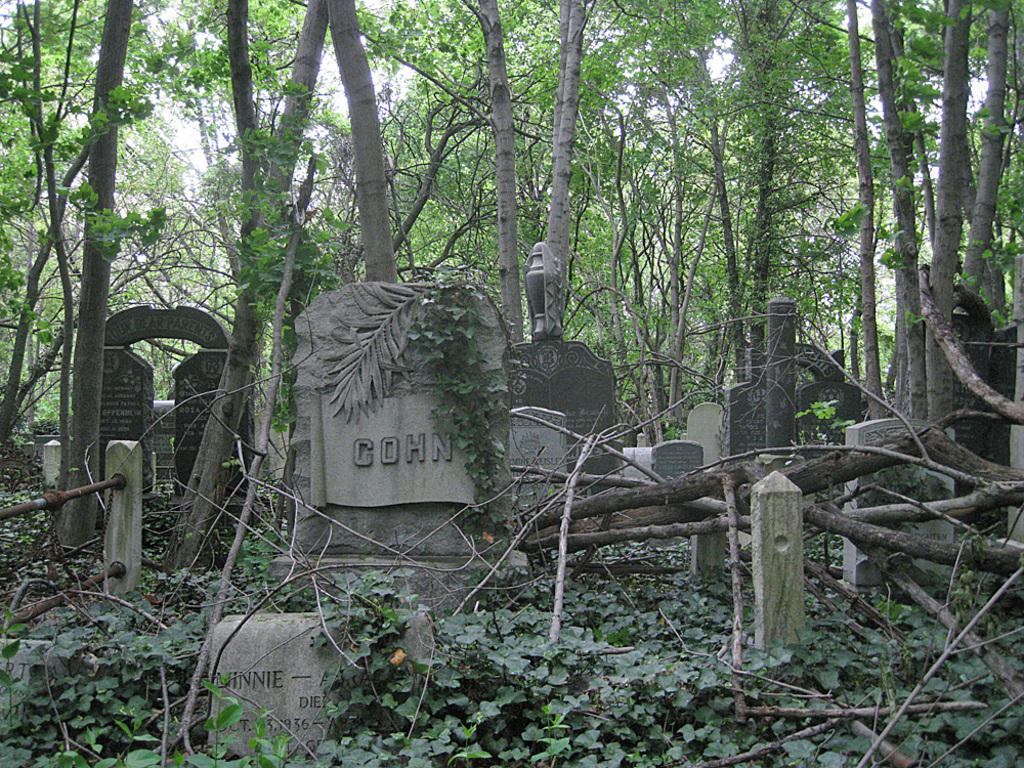What is the main setting of the picture? There is a graveyard in the picture. What can be found in the graveyard? There are grave stones in the graveyard. What type of vegetation is present in the picture? There are tree trunks and trees in the background of the picture. How would you describe the weather in the picture? The sky is clear in the picture, suggesting good weather. What is the shape of the needle in the picture? There is no needle present in the picture; it is a graveyard with grave stones, tree trunks, and trees in the background. 